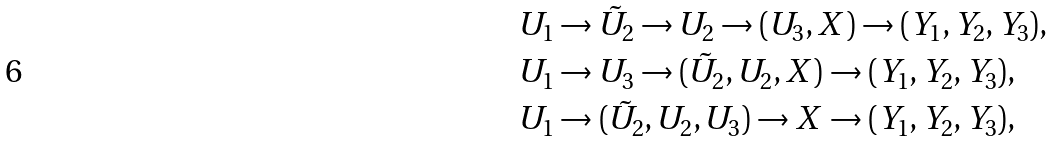<formula> <loc_0><loc_0><loc_500><loc_500>& U _ { 1 } \to \tilde { U } _ { 2 } \to U _ { 2 } \to ( U _ { 3 } , X ) \to ( Y _ { 1 } , Y _ { 2 } , Y _ { 3 } ) , \\ & U _ { 1 } \to U _ { 3 } \to ( \tilde { U } _ { 2 } , U _ { 2 } , X ) \to ( Y _ { 1 } , Y _ { 2 } , Y _ { 3 } ) , \\ & U _ { 1 } \to ( \tilde { U } _ { 2 } , U _ { 2 } , U _ { 3 } ) \to X \to ( Y _ { 1 } , Y _ { 2 } , Y _ { 3 } ) ,</formula> 